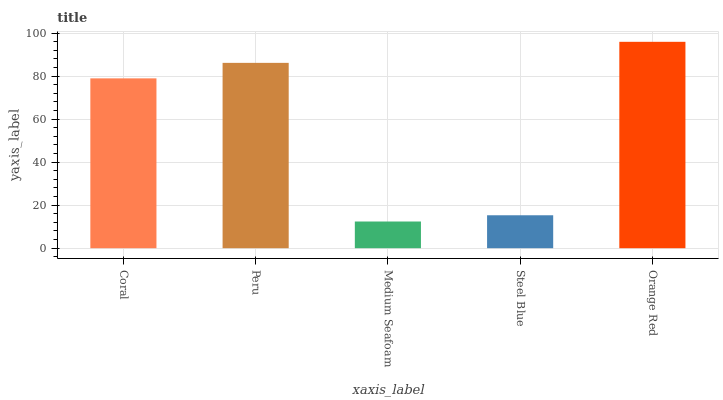Is Medium Seafoam the minimum?
Answer yes or no. Yes. Is Orange Red the maximum?
Answer yes or no. Yes. Is Peru the minimum?
Answer yes or no. No. Is Peru the maximum?
Answer yes or no. No. Is Peru greater than Coral?
Answer yes or no. Yes. Is Coral less than Peru?
Answer yes or no. Yes. Is Coral greater than Peru?
Answer yes or no. No. Is Peru less than Coral?
Answer yes or no. No. Is Coral the high median?
Answer yes or no. Yes. Is Coral the low median?
Answer yes or no. Yes. Is Medium Seafoam the high median?
Answer yes or no. No. Is Orange Red the low median?
Answer yes or no. No. 